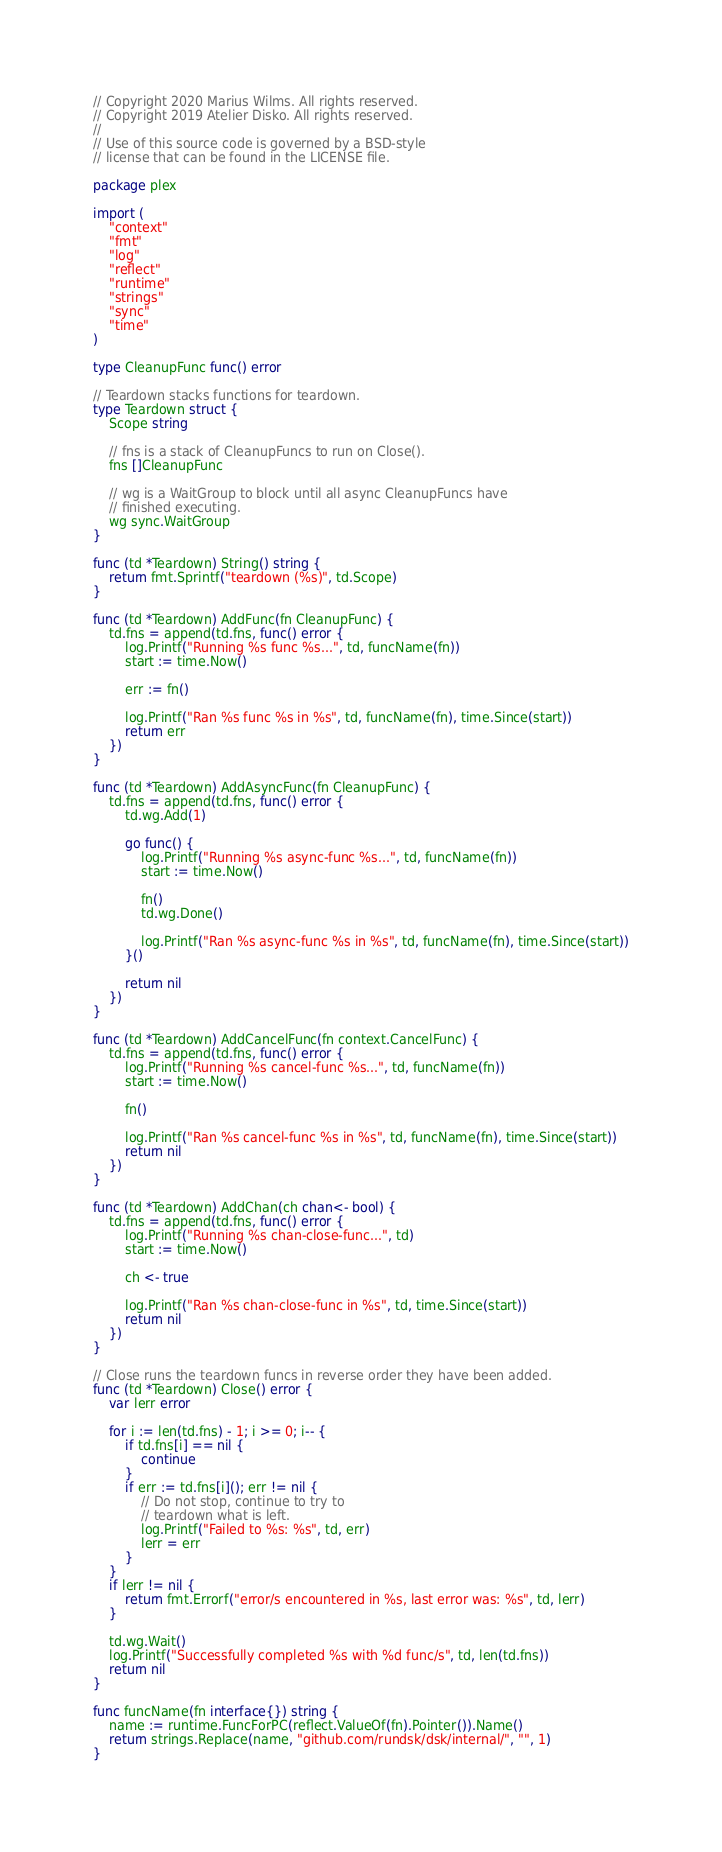<code> <loc_0><loc_0><loc_500><loc_500><_Go_>// Copyright 2020 Marius Wilms. All rights reserved.
// Copyright 2019 Atelier Disko. All rights reserved.
//
// Use of this source code is governed by a BSD-style
// license that can be found in the LICENSE file.

package plex

import (
	"context"
	"fmt"
	"log"
	"reflect"
	"runtime"
	"strings"
	"sync"
	"time"
)

type CleanupFunc func() error

// Teardown stacks functions for teardown.
type Teardown struct {
	Scope string

	// fns is a stack of CleanupFuncs to run on Close().
	fns []CleanupFunc

	// wg is a WaitGroup to block until all async CleanupFuncs have
	// finished executing.
	wg sync.WaitGroup
}

func (td *Teardown) String() string {
	return fmt.Sprintf("teardown (%s)", td.Scope)
}

func (td *Teardown) AddFunc(fn CleanupFunc) {
	td.fns = append(td.fns, func() error {
		log.Printf("Running %s func %s...", td, funcName(fn))
		start := time.Now()

		err := fn()

		log.Printf("Ran %s func %s in %s", td, funcName(fn), time.Since(start))
		return err
	})
}

func (td *Teardown) AddAsyncFunc(fn CleanupFunc) {
	td.fns = append(td.fns, func() error {
		td.wg.Add(1)

		go func() {
			log.Printf("Running %s async-func %s...", td, funcName(fn))
			start := time.Now()

			fn()
			td.wg.Done()

			log.Printf("Ran %s async-func %s in %s", td, funcName(fn), time.Since(start))
		}()

		return nil
	})
}

func (td *Teardown) AddCancelFunc(fn context.CancelFunc) {
	td.fns = append(td.fns, func() error {
		log.Printf("Running %s cancel-func %s...", td, funcName(fn))
		start := time.Now()

		fn()

		log.Printf("Ran %s cancel-func %s in %s", td, funcName(fn), time.Since(start))
		return nil
	})
}

func (td *Teardown) AddChan(ch chan<- bool) {
	td.fns = append(td.fns, func() error {
		log.Printf("Running %s chan-close-func...", td)
		start := time.Now()

		ch <- true

		log.Printf("Ran %s chan-close-func in %s", td, time.Since(start))
		return nil
	})
}

// Close runs the teardown funcs in reverse order they have been added.
func (td *Teardown) Close() error {
	var lerr error

	for i := len(td.fns) - 1; i >= 0; i-- {
		if td.fns[i] == nil {
			continue
		}
		if err := td.fns[i](); err != nil {
			// Do not stop, continue to try to
			// teardown what is left.
			log.Printf("Failed to %s: %s", td, err)
			lerr = err
		}
	}
	if lerr != nil {
		return fmt.Errorf("error/s encountered in %s, last error was: %s", td, lerr)
	}

	td.wg.Wait()
	log.Printf("Successfully completed %s with %d func/s", td, len(td.fns))
	return nil
}

func funcName(fn interface{}) string {
	name := runtime.FuncForPC(reflect.ValueOf(fn).Pointer()).Name()
	return strings.Replace(name, "github.com/rundsk/dsk/internal/", "", 1)
}
</code> 